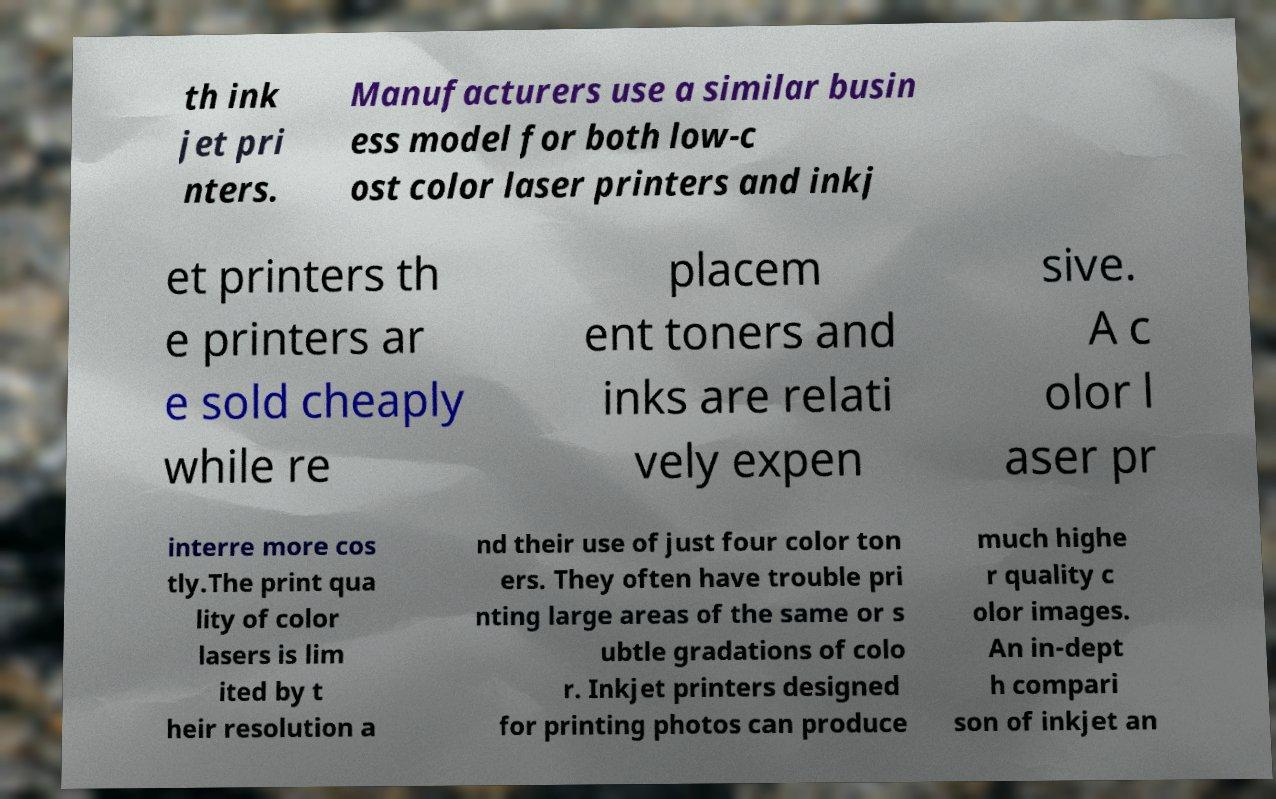What messages or text are displayed in this image? I need them in a readable, typed format. th ink jet pri nters. Manufacturers use a similar busin ess model for both low-c ost color laser printers and inkj et printers th e printers ar e sold cheaply while re placem ent toners and inks are relati vely expen sive. A c olor l aser pr interre more cos tly.The print qua lity of color lasers is lim ited by t heir resolution a nd their use of just four color ton ers. They often have trouble pri nting large areas of the same or s ubtle gradations of colo r. Inkjet printers designed for printing photos can produce much highe r quality c olor images. An in-dept h compari son of inkjet an 